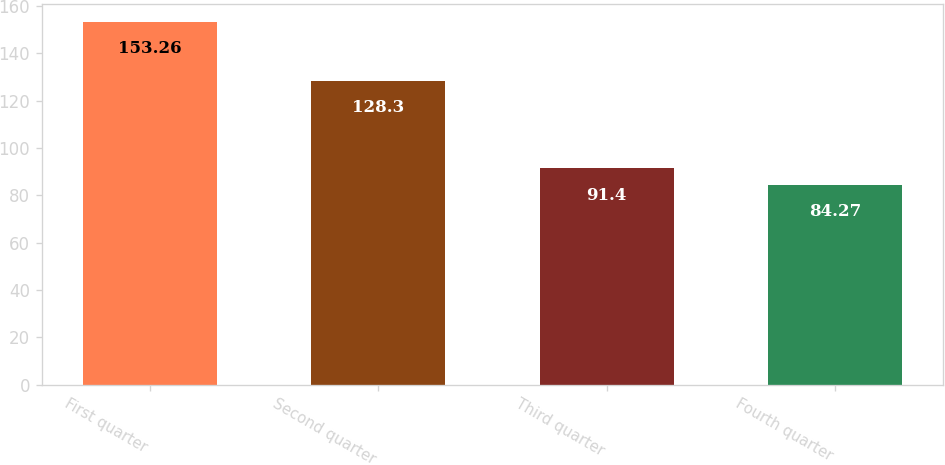Convert chart to OTSL. <chart><loc_0><loc_0><loc_500><loc_500><bar_chart><fcel>First quarter<fcel>Second quarter<fcel>Third quarter<fcel>Fourth quarter<nl><fcel>153.26<fcel>128.3<fcel>91.4<fcel>84.27<nl></chart> 